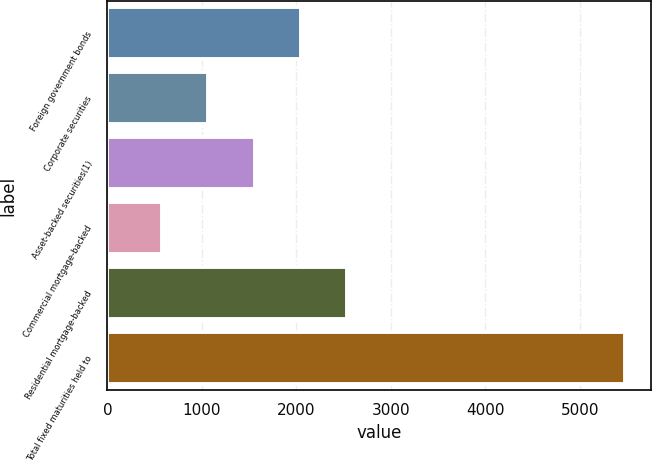<chart> <loc_0><loc_0><loc_500><loc_500><bar_chart><fcel>Foreign government bonds<fcel>Corporate securities<fcel>Asset-backed securities(1)<fcel>Commercial mortgage-backed<fcel>Residential mortgage-backed<fcel>Total fixed maturities held to<nl><fcel>2049.8<fcel>1070.6<fcel>1560.2<fcel>581<fcel>2539.4<fcel>5477<nl></chart> 